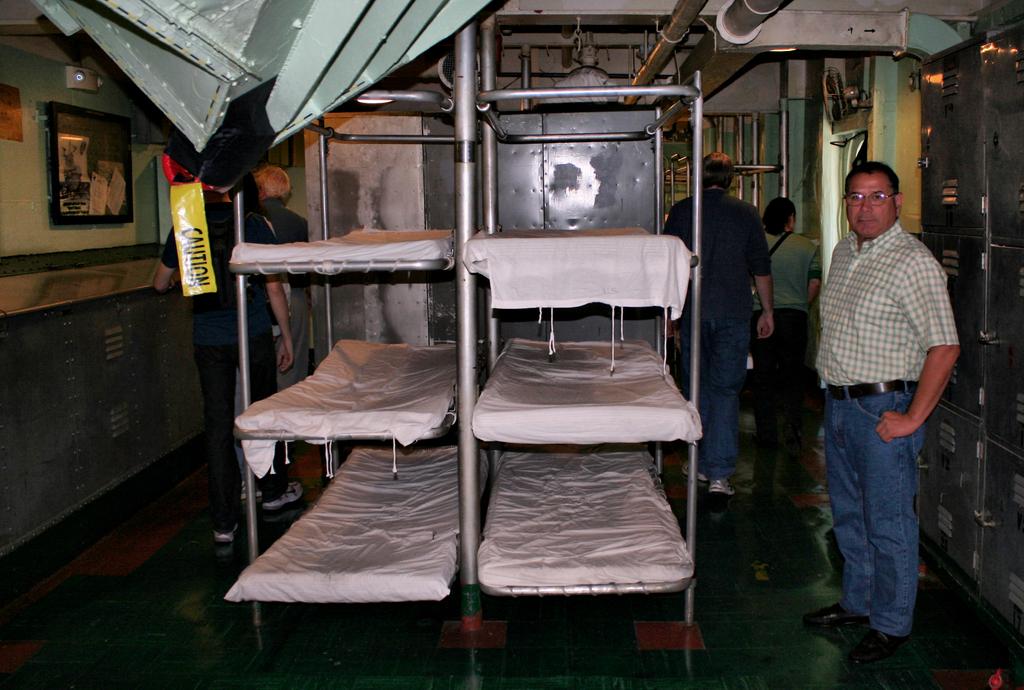What is the yellow tape saying?
Your answer should be very brief. Caution. 